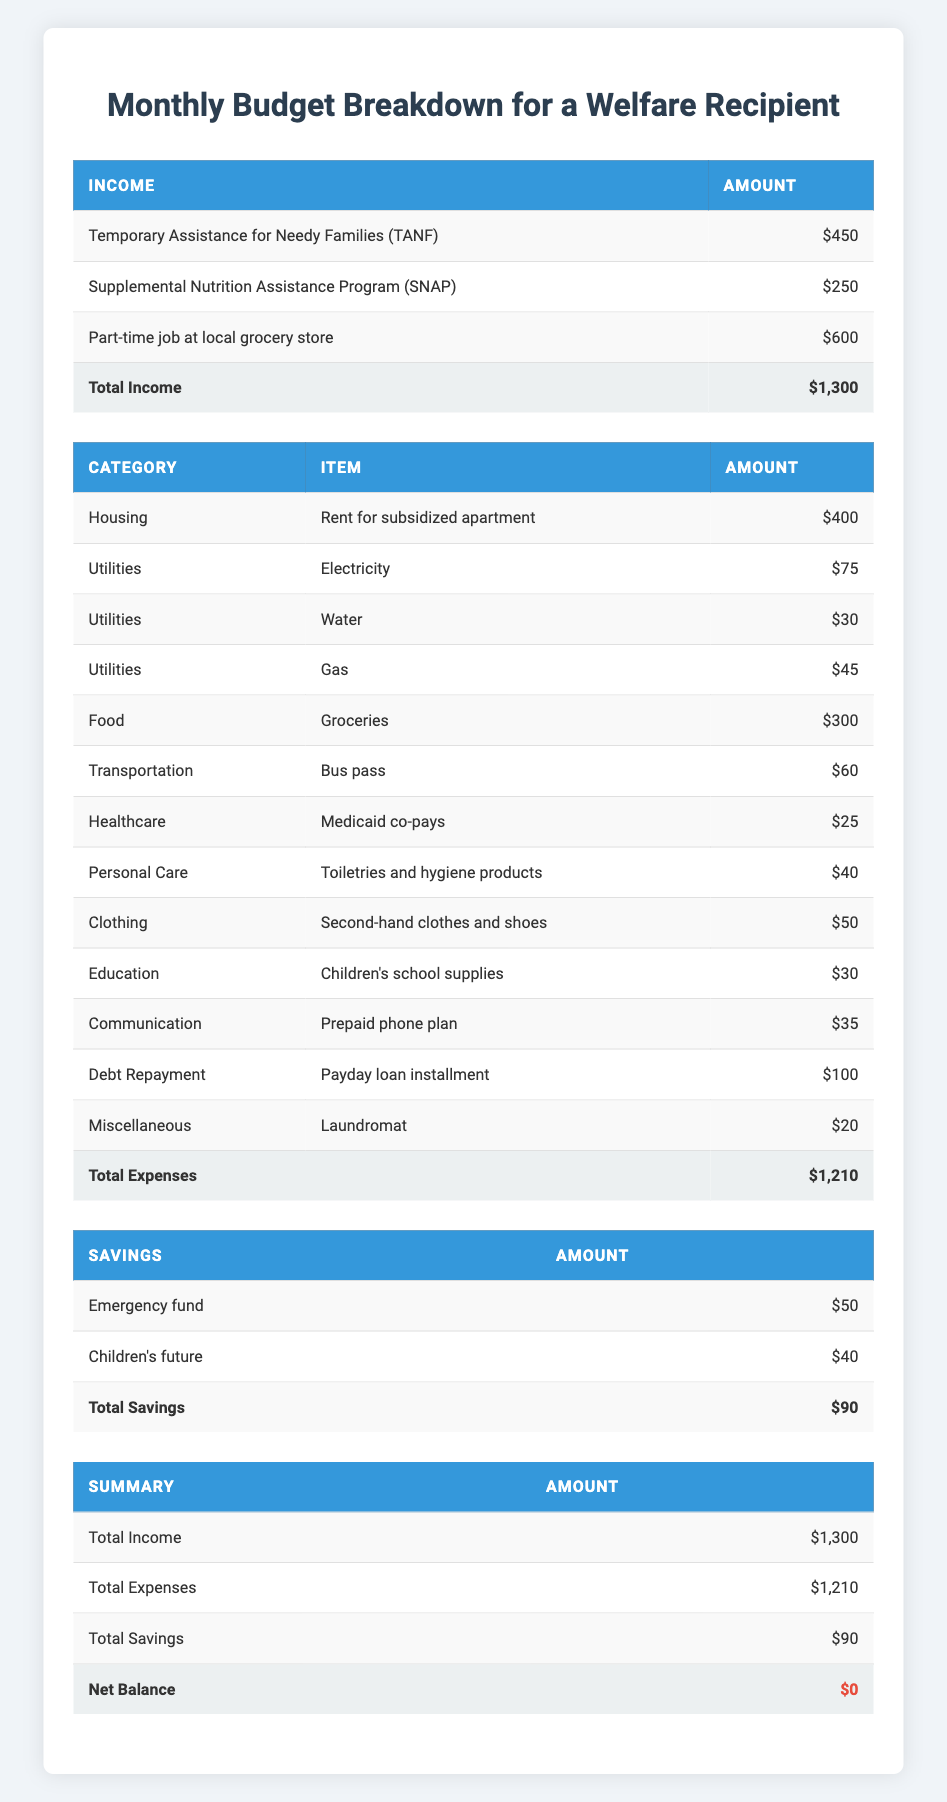What is the total amount received from Temporary Assistance for Needy Families (TANF)? The table indicates the amount received from TANF is listed under the income section, which shows $450.
Answer: 450 What are the total utility expenses? The utility expenses listed are Electricity ($75), Water ($30), and Gas ($45). Adding these amounts gives 75 + 30 + 45 = 150.
Answer: 150 Is the total income greater than the total expenses? The total income is $1,300 and the total expenses are $1,210. Since 1,300 is greater than 1,210, the statement is true.
Answer: Yes What is the total amount allocated for savings? The table shows two savings categories: Emergency fund ($50) and Children's future ($40). Adding these gives 50 + 40 = 90.
Answer: 90 If the recipient did not make any savings, how much money would they have left after expenses? The total income is $1,300 and the total expenses are $1,210. Without savings, the money left after expenses would be calculated as 1,300 - 1,210 = 90.
Answer: 90 Which category has the highest expense amount? Looking through the expenses, Rent for subsidized apartment ($400) is the highest expense. Comparing other expenses, none exceed this amount.
Answer: Housing What fraction of the total expenses is spent on food? The food expense for groceries is $300 and total expenses are $1,210. To find the fraction, you divide 300 by 1210 which simplifies to approximately 0.248 or 24.8%.
Answer: 24.8% How much is spent on transportation compared to the total expenses? The transportation expense (Bus pass) is $60. To find the spending percentage compared to total expenses, divide 60 by 1,210, which gives approximately 0.0496 or 4.96%.
Answer: 4.96% Are the total expenses and total savings equal to each other? The total expenses amount to $1,210 while the total savings amount to $90. Since these amounts are not equal, the statement is false.
Answer: No 